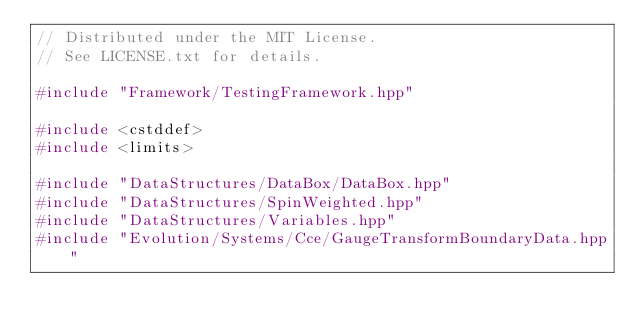<code> <loc_0><loc_0><loc_500><loc_500><_C++_>// Distributed under the MIT License.
// See LICENSE.txt for details.

#include "Framework/TestingFramework.hpp"

#include <cstddef>
#include <limits>

#include "DataStructures/DataBox/DataBox.hpp"
#include "DataStructures/SpinWeighted.hpp"
#include "DataStructures/Variables.hpp"
#include "Evolution/Systems/Cce/GaugeTransformBoundaryData.hpp"</code> 